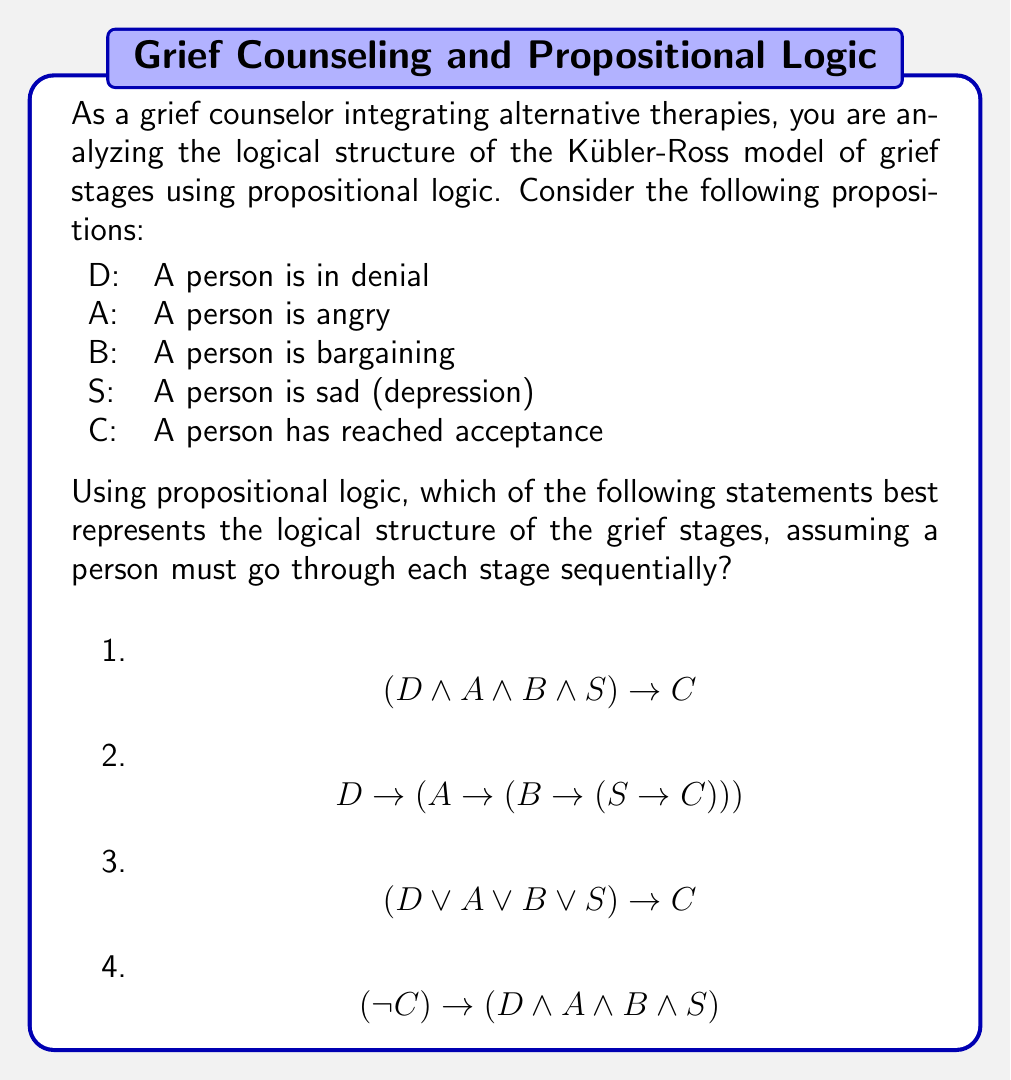Help me with this question. Let's analyze each option step-by-step:

1) $$(D \land A \land B \land S) \rightarrow C$$
This statement means that if a person is simultaneously in denial, angry, bargaining, and sad, then they will reach acceptance. This doesn't accurately represent the sequential nature of the stages.

2) $$D \rightarrow (A \rightarrow (B \rightarrow (S \rightarrow C)))$$
This statement can be interpreted as: If a person is in denial, then if they become angry, then if they start bargaining, then if they become sad, they will reach acceptance. This correctly represents the sequential nature of the stages.

3) $$(D \lor A \lor B \lor S) \rightarrow C$$
This statement suggests that if a person is in any one of the stages (denial, anger, bargaining, or sadness), they will reach acceptance. This doesn't capture the idea of going through all stages sequentially.

4) $$(\lnot C) \rightarrow (D \land A \land B \land S)$$
This statement means that if a person hasn't reached acceptance, then they must be simultaneously in all other stages. This doesn't represent the sequential nature of the stages and is logically flawed.

Therefore, option 2 best represents the logical structure of the grief stages according to the Kübler-Ross model, as it captures the sequential progression through each stage before reaching acceptance.
Answer: 2) $$D \rightarrow (A \rightarrow (B \rightarrow (S \rightarrow C)))$$ 